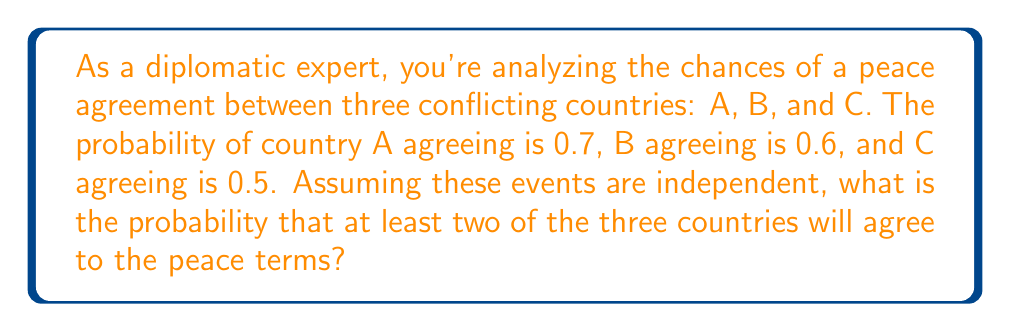Can you solve this math problem? Let's approach this step-by-step:

1) First, we need to calculate the probability of at least two countries agreeing. This is easier if we calculate the complement event (the probability of fewer than two countries agreeing) and subtract it from 1.

2) The probability of fewer than two countries agreeing is the sum of:
   - The probability that no country agrees
   - The probability that exactly one country agrees

3) Let's calculate these probabilities:

   a) Probability that no country agrees:
      $P(\text{none}) = (1-0.7)(1-0.6)(1-0.5) = 0.3 \times 0.4 \times 0.5 = 0.06$

   b) Probability that exactly one country agrees:
      $P(\text{A only}) = 0.7 \times 0.4 \times 0.5 = 0.14$
      $P(\text{B only}) = 0.3 \times 0.6 \times 0.5 = 0.09$
      $P(\text{C only}) = 0.3 \times 0.4 \times 0.5 = 0.06$

      $P(\text{exactly one}) = 0.14 + 0.09 + 0.06 = 0.29$

4) The probability of fewer than two countries agreeing:
   $P(\text{fewer than two}) = P(\text{none}) + P(\text{exactly one}) = 0.06 + 0.29 = 0.35$

5) Therefore, the probability of at least two countries agreeing is:
   $P(\text{at least two}) = 1 - P(\text{fewer than two}) = 1 - 0.35 = 0.65$
Answer: 0.65 